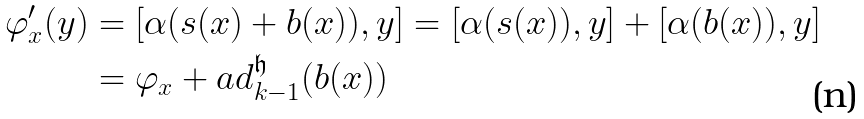<formula> <loc_0><loc_0><loc_500><loc_500>\varphi ^ { \prime } _ { x } ( y ) & = [ \alpha ( s ( x ) + b ( x ) ) , y ] = [ \alpha ( s ( x ) ) , y ] + [ \alpha ( b ( x ) ) , y ] \\ & = \varphi _ { x } + a d _ { k - 1 } ^ { \mathfrak { h } } ( b ( x ) )</formula> 